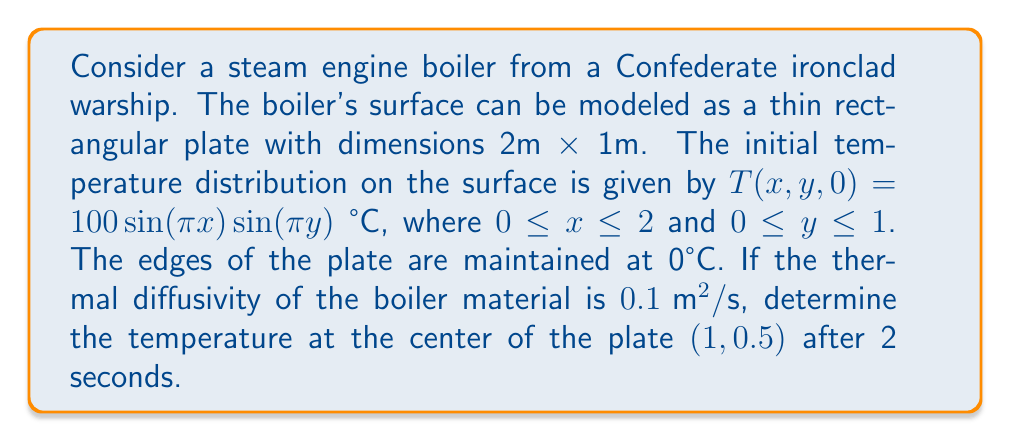Can you answer this question? To solve this problem, we need to use the 2D heat equation:

$$\frac{\partial T}{\partial t} = \alpha \left(\frac{\partial^2 T}{\partial x^2} + \frac{\partial^2 T}{\partial y^2}\right)$$

where $\alpha$ is the thermal diffusivity.

Given the initial condition and boundary conditions, we can use the method of separation of variables. The solution takes the form:

$$T(x,y,t) = \sum_{m=1}^{\infty}\sum_{n=1}^{\infty} A_{mn} \sin\left(\frac{m\pi x}{L_x}\right) \sin\left(\frac{n\pi y}{L_y}\right) e^{-\alpha t (\frac{m^2\pi^2}{L_x^2} + \frac{n^2\pi^2}{L_y^2})}$$

where $L_x = 2$ and $L_y = 1$.

Comparing this with the initial condition, we can see that only the term with $m=1$ and $n=1$ is non-zero, and $A_{11} = 100$. Therefore, the solution simplifies to:

$$T(x,y,t) = 100 \sin\left(\frac{\pi x}{2}\right) \sin(\pi y) e^{-\alpha t (\frac{\pi^2}{4} + \pi^2)}$$

Now, we can calculate the temperature at the center $(1,0.5)$ after 2 seconds:

$$T(1,0.5,2) = 100 \sin\left(\frac{\pi}{2}\right) \sin\left(\frac{\pi}{2}\right) e^{-0.1 \cdot 2 (\frac{\pi^2}{4} + \pi^2)}$$

$$= 100 \cdot 1 \cdot 1 \cdot e^{-0.2 (\frac{\pi^2}{4} + \pi^2)}$$

$$= 100 e^{-0.2 (2.47 + 9.87)}$$

$$= 100 e^{-2.468}$$

$$\approx 8.47 \text{ °C}$$
Answer: The temperature at the center of the Confederate ironclad's boiler plate $(1,0.5)$ after 2 seconds is approximately 8.47 °C. 